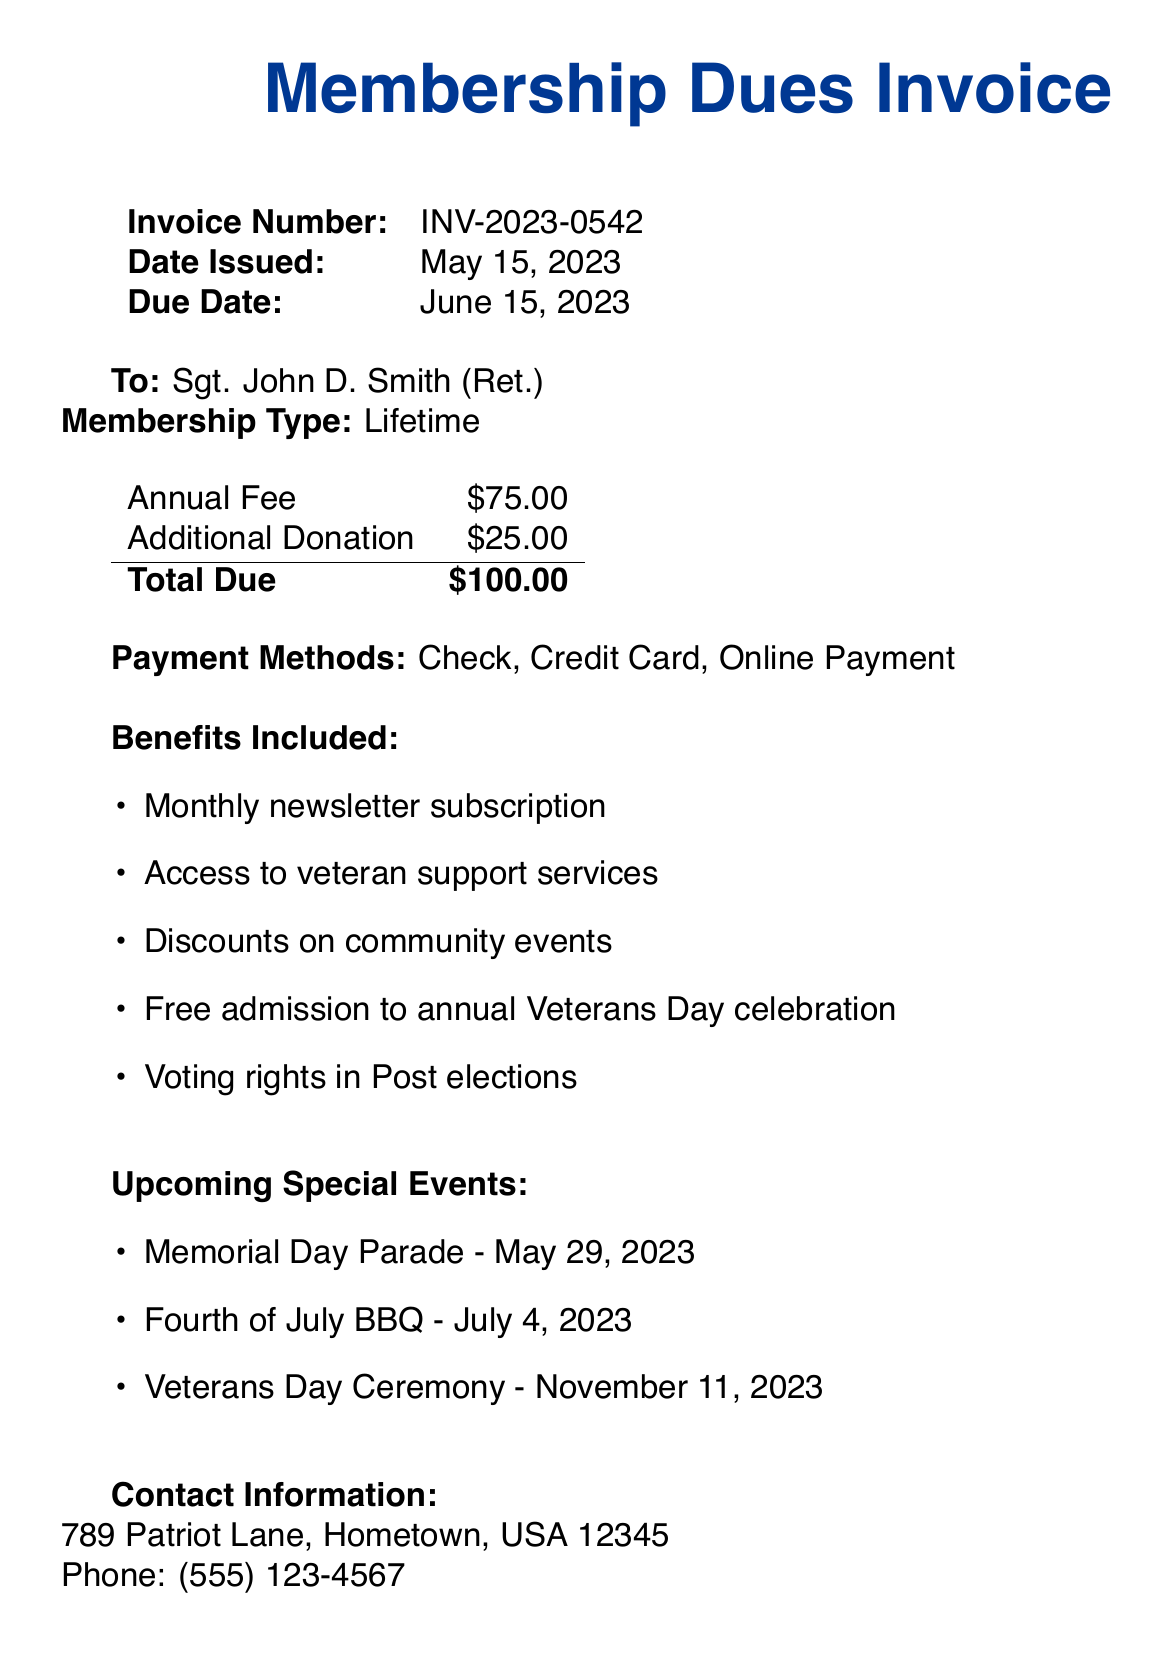what is the organization name? The organization name is stated at the top of the invoice.
Answer: American Legion Post 123 what is the invoice number? The invoice number is listed under the invoice details section.
Answer: INV-2023-0542 what is the total due amount? The total due is the final figure calculating the annual fee and additional donation.
Answer: $100.00 when was the invoice issued? The date issued is provided on the invoice details section.
Answer: May 15, 2023 who is the member named in the invoice? The member's name is mentioned directly in the document.
Answer: Sgt. John D. Smith (Ret.) what is one benefit included with the membership? The benefits are listed as items in the benefits section of the document.
Answer: Monthly newsletter subscription what are the payment methods? The payment methods are explicitly mentioned in the payment methods section.
Answer: Check, Credit Card, Online Payment how many upcoming special events are listed? The number of special events can be counted from the special events section.
Answer: 3 what is the due date for the payment? The due date is highlighted in the invoice details section.
Answer: June 15, 2023 what note is provided in the additional notes section? The note provides context and appreciation to the member, found at the bottom.
Answer: As a retired Marine Corps veteran and community organizer, your continued support helps us maintain our strong veteran network and organize events that bring our neighborhood together. Thank you for your service and dedication to our community 